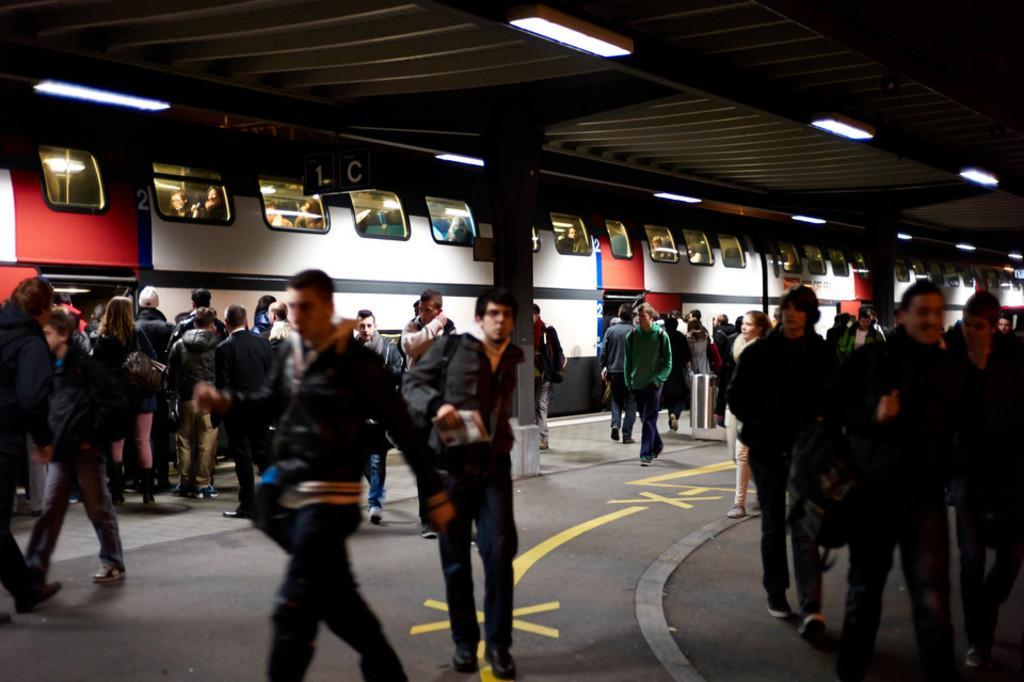How would you summarize this image in a sentence or two? In this image I can see the platform, few pillars, the ceiling, few lights to the ceiling and number of persons standing on the platform. I can see a train which is red, white and black in color and in the train I can see few lights and few persons. 